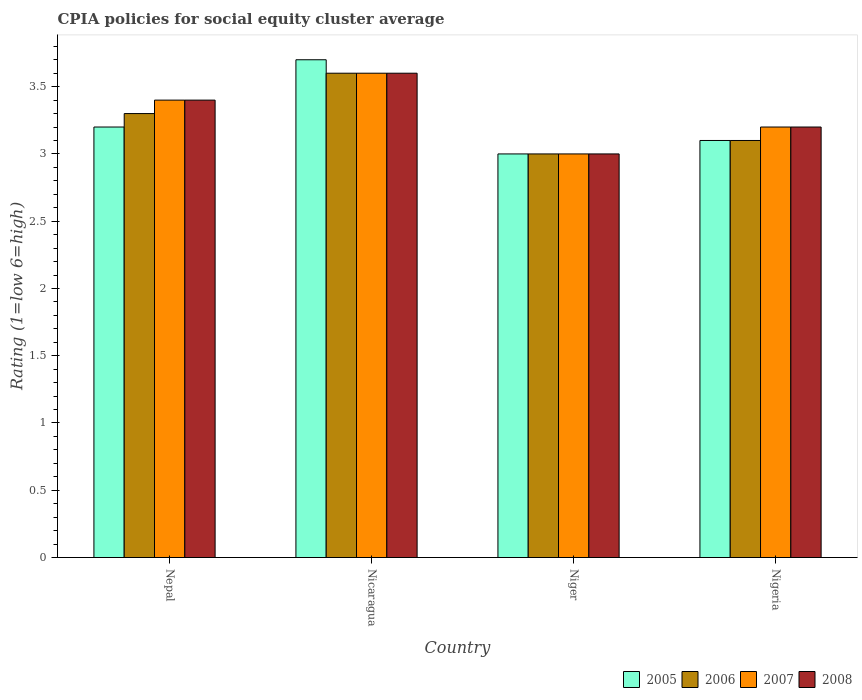How many different coloured bars are there?
Give a very brief answer. 4. How many groups of bars are there?
Provide a short and direct response. 4. Are the number of bars on each tick of the X-axis equal?
Give a very brief answer. Yes. How many bars are there on the 1st tick from the left?
Provide a succinct answer. 4. What is the label of the 1st group of bars from the left?
Offer a very short reply. Nepal. In how many cases, is the number of bars for a given country not equal to the number of legend labels?
Make the answer very short. 0. What is the CPIA rating in 2006 in Nicaragua?
Give a very brief answer. 3.6. In which country was the CPIA rating in 2005 maximum?
Provide a short and direct response. Nicaragua. In which country was the CPIA rating in 2005 minimum?
Your response must be concise. Niger. What is the difference between the CPIA rating in 2007 in Nepal and that in Nigeria?
Provide a succinct answer. 0.2. What is the difference between the CPIA rating of/in 2008 and CPIA rating of/in 2006 in Nigeria?
Offer a terse response. 0.1. What is the ratio of the CPIA rating in 2007 in Nicaragua to that in Nigeria?
Provide a short and direct response. 1.12. What is the difference between the highest and the lowest CPIA rating in 2007?
Give a very brief answer. 0.6. Is it the case that in every country, the sum of the CPIA rating in 2008 and CPIA rating in 2007 is greater than the sum of CPIA rating in 2005 and CPIA rating in 2006?
Provide a succinct answer. No. Is it the case that in every country, the sum of the CPIA rating in 2008 and CPIA rating in 2007 is greater than the CPIA rating in 2005?
Ensure brevity in your answer.  Yes. Are the values on the major ticks of Y-axis written in scientific E-notation?
Provide a succinct answer. No. Where does the legend appear in the graph?
Your answer should be compact. Bottom right. How many legend labels are there?
Ensure brevity in your answer.  4. What is the title of the graph?
Your answer should be compact. CPIA policies for social equity cluster average. What is the Rating (1=low 6=high) in 2005 in Nepal?
Your answer should be compact. 3.2. What is the Rating (1=low 6=high) of 2006 in Nepal?
Your response must be concise. 3.3. What is the Rating (1=low 6=high) in 2007 in Nepal?
Your response must be concise. 3.4. What is the Rating (1=low 6=high) of 2008 in Nicaragua?
Provide a short and direct response. 3.6. What is the Rating (1=low 6=high) of 2007 in Niger?
Offer a terse response. 3. What is the Rating (1=low 6=high) of 2005 in Nigeria?
Make the answer very short. 3.1. What is the Rating (1=low 6=high) of 2008 in Nigeria?
Your response must be concise. 3.2. Across all countries, what is the maximum Rating (1=low 6=high) of 2008?
Give a very brief answer. 3.6. Across all countries, what is the minimum Rating (1=low 6=high) of 2005?
Your answer should be very brief. 3. Across all countries, what is the minimum Rating (1=low 6=high) in 2006?
Give a very brief answer. 3. Across all countries, what is the minimum Rating (1=low 6=high) in 2007?
Keep it short and to the point. 3. What is the total Rating (1=low 6=high) of 2005 in the graph?
Make the answer very short. 13. What is the total Rating (1=low 6=high) in 2006 in the graph?
Provide a succinct answer. 13. What is the total Rating (1=low 6=high) in 2007 in the graph?
Provide a short and direct response. 13.2. What is the total Rating (1=low 6=high) of 2008 in the graph?
Your answer should be very brief. 13.2. What is the difference between the Rating (1=low 6=high) in 2005 in Nepal and that in Nicaragua?
Give a very brief answer. -0.5. What is the difference between the Rating (1=low 6=high) of 2006 in Nepal and that in Nicaragua?
Ensure brevity in your answer.  -0.3. What is the difference between the Rating (1=low 6=high) in 2008 in Nepal and that in Nicaragua?
Give a very brief answer. -0.2. What is the difference between the Rating (1=low 6=high) in 2006 in Nepal and that in Niger?
Ensure brevity in your answer.  0.3. What is the difference between the Rating (1=low 6=high) of 2007 in Nepal and that in Niger?
Keep it short and to the point. 0.4. What is the difference between the Rating (1=low 6=high) of 2008 in Nepal and that in Niger?
Give a very brief answer. 0.4. What is the difference between the Rating (1=low 6=high) in 2005 in Nepal and that in Nigeria?
Offer a terse response. 0.1. What is the difference between the Rating (1=low 6=high) of 2006 in Nepal and that in Nigeria?
Keep it short and to the point. 0.2. What is the difference between the Rating (1=low 6=high) in 2008 in Nepal and that in Nigeria?
Your response must be concise. 0.2. What is the difference between the Rating (1=low 6=high) of 2005 in Nicaragua and that in Niger?
Provide a succinct answer. 0.7. What is the difference between the Rating (1=low 6=high) in 2007 in Nicaragua and that in Niger?
Make the answer very short. 0.6. What is the difference between the Rating (1=low 6=high) in 2006 in Nicaragua and that in Nigeria?
Your answer should be very brief. 0.5. What is the difference between the Rating (1=low 6=high) in 2005 in Niger and that in Nigeria?
Your answer should be very brief. -0.1. What is the difference between the Rating (1=low 6=high) of 2005 in Nepal and the Rating (1=low 6=high) of 2006 in Nicaragua?
Your answer should be very brief. -0.4. What is the difference between the Rating (1=low 6=high) in 2006 in Nepal and the Rating (1=low 6=high) in 2008 in Nicaragua?
Your answer should be very brief. -0.3. What is the difference between the Rating (1=low 6=high) in 2007 in Nepal and the Rating (1=low 6=high) in 2008 in Nicaragua?
Your response must be concise. -0.2. What is the difference between the Rating (1=low 6=high) of 2005 in Nepal and the Rating (1=low 6=high) of 2007 in Niger?
Provide a short and direct response. 0.2. What is the difference between the Rating (1=low 6=high) of 2005 in Nepal and the Rating (1=low 6=high) of 2008 in Niger?
Your answer should be compact. 0.2. What is the difference between the Rating (1=low 6=high) of 2006 in Nepal and the Rating (1=low 6=high) of 2007 in Niger?
Provide a short and direct response. 0.3. What is the difference between the Rating (1=low 6=high) in 2007 in Nepal and the Rating (1=low 6=high) in 2008 in Niger?
Make the answer very short. 0.4. What is the difference between the Rating (1=low 6=high) of 2005 in Nepal and the Rating (1=low 6=high) of 2006 in Nigeria?
Give a very brief answer. 0.1. What is the difference between the Rating (1=low 6=high) of 2005 in Nepal and the Rating (1=low 6=high) of 2007 in Nigeria?
Make the answer very short. 0. What is the difference between the Rating (1=low 6=high) in 2005 in Nicaragua and the Rating (1=low 6=high) in 2007 in Niger?
Your response must be concise. 0.7. What is the difference between the Rating (1=low 6=high) of 2005 in Nicaragua and the Rating (1=low 6=high) of 2008 in Niger?
Give a very brief answer. 0.7. What is the difference between the Rating (1=low 6=high) in 2006 in Nicaragua and the Rating (1=low 6=high) in 2008 in Niger?
Make the answer very short. 0.6. What is the difference between the Rating (1=low 6=high) in 2005 in Nicaragua and the Rating (1=low 6=high) in 2007 in Nigeria?
Keep it short and to the point. 0.5. What is the difference between the Rating (1=low 6=high) in 2006 in Nicaragua and the Rating (1=low 6=high) in 2008 in Nigeria?
Your response must be concise. 0.4. What is the difference between the Rating (1=low 6=high) of 2007 in Nicaragua and the Rating (1=low 6=high) of 2008 in Nigeria?
Your answer should be very brief. 0.4. What is the difference between the Rating (1=low 6=high) of 2005 in Niger and the Rating (1=low 6=high) of 2006 in Nigeria?
Provide a short and direct response. -0.1. What is the difference between the Rating (1=low 6=high) of 2005 in Niger and the Rating (1=low 6=high) of 2007 in Nigeria?
Make the answer very short. -0.2. What is the difference between the Rating (1=low 6=high) in 2007 in Niger and the Rating (1=low 6=high) in 2008 in Nigeria?
Offer a very short reply. -0.2. What is the difference between the Rating (1=low 6=high) in 2005 and Rating (1=low 6=high) in 2008 in Nepal?
Your response must be concise. -0.2. What is the difference between the Rating (1=low 6=high) in 2006 and Rating (1=low 6=high) in 2007 in Nepal?
Your answer should be very brief. -0.1. What is the difference between the Rating (1=low 6=high) in 2006 and Rating (1=low 6=high) in 2008 in Nepal?
Keep it short and to the point. -0.1. What is the difference between the Rating (1=low 6=high) of 2007 and Rating (1=low 6=high) of 2008 in Nepal?
Your answer should be very brief. 0. What is the difference between the Rating (1=low 6=high) in 2005 and Rating (1=low 6=high) in 2006 in Nicaragua?
Make the answer very short. 0.1. What is the difference between the Rating (1=low 6=high) of 2005 and Rating (1=low 6=high) of 2008 in Nicaragua?
Provide a short and direct response. 0.1. What is the difference between the Rating (1=low 6=high) of 2006 and Rating (1=low 6=high) of 2007 in Nicaragua?
Provide a short and direct response. 0. What is the difference between the Rating (1=low 6=high) of 2006 and Rating (1=low 6=high) of 2008 in Nicaragua?
Ensure brevity in your answer.  0. What is the difference between the Rating (1=low 6=high) in 2007 and Rating (1=low 6=high) in 2008 in Nicaragua?
Provide a succinct answer. 0. What is the difference between the Rating (1=low 6=high) in 2005 and Rating (1=low 6=high) in 2006 in Niger?
Offer a very short reply. 0. What is the difference between the Rating (1=low 6=high) in 2006 and Rating (1=low 6=high) in 2007 in Niger?
Offer a very short reply. 0. What is the difference between the Rating (1=low 6=high) of 2005 and Rating (1=low 6=high) of 2006 in Nigeria?
Your answer should be compact. 0. What is the difference between the Rating (1=low 6=high) in 2005 and Rating (1=low 6=high) in 2007 in Nigeria?
Offer a very short reply. -0.1. What is the difference between the Rating (1=low 6=high) in 2006 and Rating (1=low 6=high) in 2007 in Nigeria?
Make the answer very short. -0.1. What is the difference between the Rating (1=low 6=high) of 2007 and Rating (1=low 6=high) of 2008 in Nigeria?
Your response must be concise. 0. What is the ratio of the Rating (1=low 6=high) of 2005 in Nepal to that in Nicaragua?
Make the answer very short. 0.86. What is the ratio of the Rating (1=low 6=high) in 2006 in Nepal to that in Nicaragua?
Offer a very short reply. 0.92. What is the ratio of the Rating (1=low 6=high) in 2005 in Nepal to that in Niger?
Ensure brevity in your answer.  1.07. What is the ratio of the Rating (1=low 6=high) of 2007 in Nepal to that in Niger?
Make the answer very short. 1.13. What is the ratio of the Rating (1=low 6=high) in 2008 in Nepal to that in Niger?
Ensure brevity in your answer.  1.13. What is the ratio of the Rating (1=low 6=high) in 2005 in Nepal to that in Nigeria?
Keep it short and to the point. 1.03. What is the ratio of the Rating (1=low 6=high) of 2006 in Nepal to that in Nigeria?
Give a very brief answer. 1.06. What is the ratio of the Rating (1=low 6=high) in 2005 in Nicaragua to that in Niger?
Your answer should be very brief. 1.23. What is the ratio of the Rating (1=low 6=high) in 2007 in Nicaragua to that in Niger?
Your answer should be compact. 1.2. What is the ratio of the Rating (1=low 6=high) of 2005 in Nicaragua to that in Nigeria?
Your answer should be compact. 1.19. What is the ratio of the Rating (1=low 6=high) of 2006 in Nicaragua to that in Nigeria?
Make the answer very short. 1.16. What is the ratio of the Rating (1=low 6=high) of 2007 in Nicaragua to that in Nigeria?
Offer a very short reply. 1.12. What is the ratio of the Rating (1=low 6=high) in 2008 in Nicaragua to that in Nigeria?
Ensure brevity in your answer.  1.12. What is the ratio of the Rating (1=low 6=high) in 2005 in Niger to that in Nigeria?
Offer a terse response. 0.97. What is the ratio of the Rating (1=low 6=high) in 2006 in Niger to that in Nigeria?
Your response must be concise. 0.97. What is the ratio of the Rating (1=low 6=high) in 2007 in Niger to that in Nigeria?
Your response must be concise. 0.94. What is the difference between the highest and the second highest Rating (1=low 6=high) in 2006?
Keep it short and to the point. 0.3. What is the difference between the highest and the second highest Rating (1=low 6=high) of 2007?
Your response must be concise. 0.2. What is the difference between the highest and the lowest Rating (1=low 6=high) in 2005?
Ensure brevity in your answer.  0.7. 